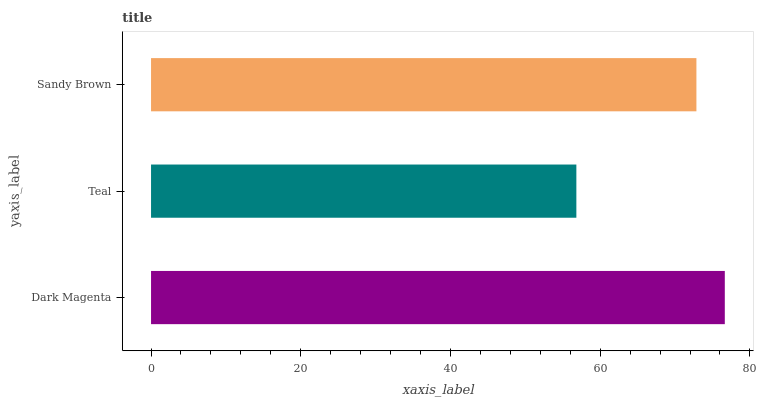Is Teal the minimum?
Answer yes or no. Yes. Is Dark Magenta the maximum?
Answer yes or no. Yes. Is Sandy Brown the minimum?
Answer yes or no. No. Is Sandy Brown the maximum?
Answer yes or no. No. Is Sandy Brown greater than Teal?
Answer yes or no. Yes. Is Teal less than Sandy Brown?
Answer yes or no. Yes. Is Teal greater than Sandy Brown?
Answer yes or no. No. Is Sandy Brown less than Teal?
Answer yes or no. No. Is Sandy Brown the high median?
Answer yes or no. Yes. Is Sandy Brown the low median?
Answer yes or no. Yes. Is Dark Magenta the high median?
Answer yes or no. No. Is Teal the low median?
Answer yes or no. No. 